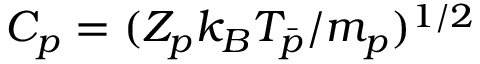Convert formula to latex. <formula><loc_0><loc_0><loc_500><loc_500>C _ { p } = ( Z _ { p } k _ { B } T _ { \bar { p } } / m _ { p } ) ^ { 1 / 2 }</formula> 